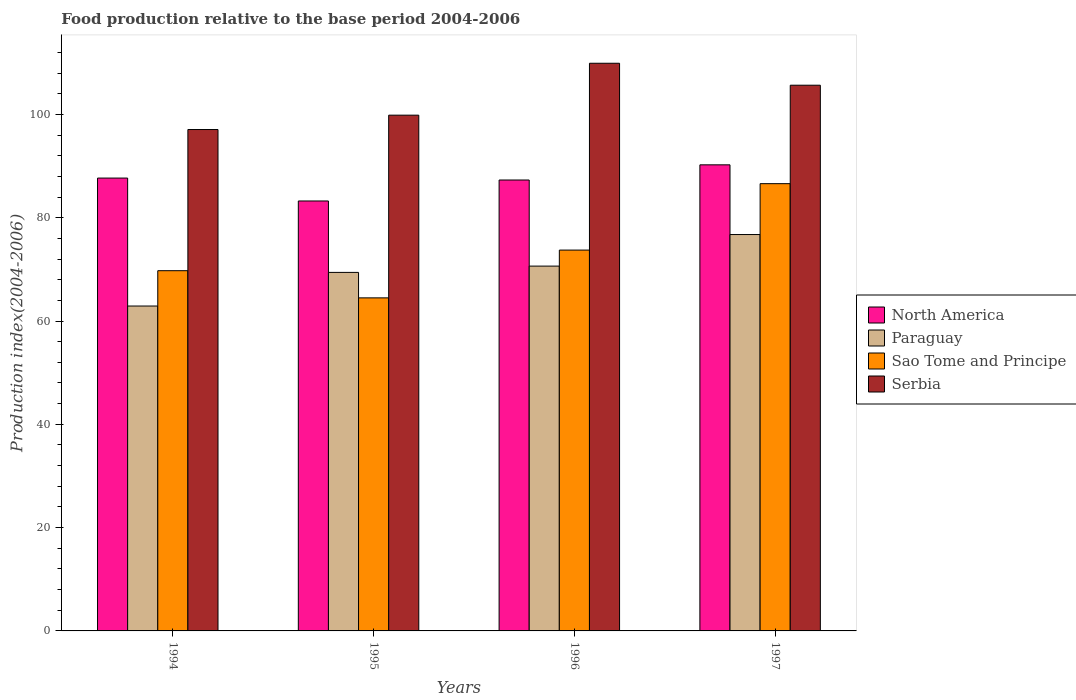How many different coloured bars are there?
Offer a very short reply. 4. Are the number of bars per tick equal to the number of legend labels?
Provide a succinct answer. Yes. How many bars are there on the 2nd tick from the left?
Provide a succinct answer. 4. What is the food production index in Serbia in 1995?
Keep it short and to the point. 99.85. Across all years, what is the maximum food production index in Paraguay?
Your response must be concise. 76.74. Across all years, what is the minimum food production index in Sao Tome and Principe?
Your answer should be compact. 64.48. In which year was the food production index in Sao Tome and Principe minimum?
Keep it short and to the point. 1995. What is the total food production index in Paraguay in the graph?
Your answer should be very brief. 279.68. What is the difference between the food production index in Sao Tome and Principe in 1994 and that in 1997?
Offer a terse response. -16.85. What is the difference between the food production index in Sao Tome and Principe in 1997 and the food production index in North America in 1994?
Keep it short and to the point. -1.08. What is the average food production index in Sao Tome and Principe per year?
Provide a succinct answer. 73.63. In the year 1994, what is the difference between the food production index in Serbia and food production index in North America?
Provide a succinct answer. 9.4. What is the ratio of the food production index in Sao Tome and Principe in 1995 to that in 1997?
Your response must be concise. 0.74. What is the difference between the highest and the second highest food production index in Sao Tome and Principe?
Offer a very short reply. 12.86. What is the difference between the highest and the lowest food production index in North America?
Offer a very short reply. 7. Is the sum of the food production index in North America in 1994 and 1995 greater than the maximum food production index in Paraguay across all years?
Your answer should be very brief. Yes. Is it the case that in every year, the sum of the food production index in Paraguay and food production index in North America is greater than the sum of food production index in Sao Tome and Principe and food production index in Serbia?
Offer a terse response. No. What does the 1st bar from the left in 1997 represents?
Your answer should be compact. North America. What does the 2nd bar from the right in 1997 represents?
Provide a succinct answer. Sao Tome and Principe. What is the difference between two consecutive major ticks on the Y-axis?
Offer a very short reply. 20. Does the graph contain grids?
Keep it short and to the point. No. Where does the legend appear in the graph?
Your answer should be compact. Center right. How many legend labels are there?
Ensure brevity in your answer.  4. How are the legend labels stacked?
Your answer should be very brief. Vertical. What is the title of the graph?
Provide a succinct answer. Food production relative to the base period 2004-2006. What is the label or title of the X-axis?
Give a very brief answer. Years. What is the label or title of the Y-axis?
Offer a very short reply. Production index(2004-2006). What is the Production index(2004-2006) of North America in 1994?
Offer a terse response. 87.67. What is the Production index(2004-2006) of Paraguay in 1994?
Make the answer very short. 62.9. What is the Production index(2004-2006) in Sao Tome and Principe in 1994?
Offer a terse response. 69.74. What is the Production index(2004-2006) in Serbia in 1994?
Give a very brief answer. 97.07. What is the Production index(2004-2006) in North America in 1995?
Ensure brevity in your answer.  83.24. What is the Production index(2004-2006) in Paraguay in 1995?
Your answer should be compact. 69.41. What is the Production index(2004-2006) in Sao Tome and Principe in 1995?
Provide a succinct answer. 64.48. What is the Production index(2004-2006) of Serbia in 1995?
Give a very brief answer. 99.85. What is the Production index(2004-2006) of North America in 1996?
Your answer should be compact. 87.3. What is the Production index(2004-2006) of Paraguay in 1996?
Provide a short and direct response. 70.63. What is the Production index(2004-2006) in Sao Tome and Principe in 1996?
Offer a very short reply. 73.73. What is the Production index(2004-2006) in Serbia in 1996?
Offer a terse response. 109.9. What is the Production index(2004-2006) in North America in 1997?
Make the answer very short. 90.24. What is the Production index(2004-2006) in Paraguay in 1997?
Your answer should be very brief. 76.74. What is the Production index(2004-2006) of Sao Tome and Principe in 1997?
Give a very brief answer. 86.59. What is the Production index(2004-2006) in Serbia in 1997?
Your answer should be very brief. 105.65. Across all years, what is the maximum Production index(2004-2006) of North America?
Offer a very short reply. 90.24. Across all years, what is the maximum Production index(2004-2006) of Paraguay?
Keep it short and to the point. 76.74. Across all years, what is the maximum Production index(2004-2006) of Sao Tome and Principe?
Make the answer very short. 86.59. Across all years, what is the maximum Production index(2004-2006) in Serbia?
Offer a terse response. 109.9. Across all years, what is the minimum Production index(2004-2006) in North America?
Offer a very short reply. 83.24. Across all years, what is the minimum Production index(2004-2006) of Paraguay?
Offer a terse response. 62.9. Across all years, what is the minimum Production index(2004-2006) of Sao Tome and Principe?
Make the answer very short. 64.48. Across all years, what is the minimum Production index(2004-2006) in Serbia?
Offer a very short reply. 97.07. What is the total Production index(2004-2006) of North America in the graph?
Keep it short and to the point. 348.44. What is the total Production index(2004-2006) of Paraguay in the graph?
Make the answer very short. 279.68. What is the total Production index(2004-2006) of Sao Tome and Principe in the graph?
Your answer should be compact. 294.54. What is the total Production index(2004-2006) of Serbia in the graph?
Your response must be concise. 412.47. What is the difference between the Production index(2004-2006) in North America in 1994 and that in 1995?
Ensure brevity in your answer.  4.44. What is the difference between the Production index(2004-2006) in Paraguay in 1994 and that in 1995?
Your response must be concise. -6.51. What is the difference between the Production index(2004-2006) of Sao Tome and Principe in 1994 and that in 1995?
Offer a very short reply. 5.26. What is the difference between the Production index(2004-2006) in Serbia in 1994 and that in 1995?
Ensure brevity in your answer.  -2.78. What is the difference between the Production index(2004-2006) in North America in 1994 and that in 1996?
Offer a terse response. 0.38. What is the difference between the Production index(2004-2006) of Paraguay in 1994 and that in 1996?
Your answer should be very brief. -7.73. What is the difference between the Production index(2004-2006) in Sao Tome and Principe in 1994 and that in 1996?
Your response must be concise. -3.99. What is the difference between the Production index(2004-2006) in Serbia in 1994 and that in 1996?
Make the answer very short. -12.83. What is the difference between the Production index(2004-2006) in North America in 1994 and that in 1997?
Make the answer very short. -2.56. What is the difference between the Production index(2004-2006) in Paraguay in 1994 and that in 1997?
Ensure brevity in your answer.  -13.84. What is the difference between the Production index(2004-2006) in Sao Tome and Principe in 1994 and that in 1997?
Give a very brief answer. -16.85. What is the difference between the Production index(2004-2006) in Serbia in 1994 and that in 1997?
Offer a terse response. -8.58. What is the difference between the Production index(2004-2006) in North America in 1995 and that in 1996?
Your response must be concise. -4.06. What is the difference between the Production index(2004-2006) in Paraguay in 1995 and that in 1996?
Give a very brief answer. -1.22. What is the difference between the Production index(2004-2006) in Sao Tome and Principe in 1995 and that in 1996?
Your response must be concise. -9.25. What is the difference between the Production index(2004-2006) in Serbia in 1995 and that in 1996?
Provide a short and direct response. -10.05. What is the difference between the Production index(2004-2006) in North America in 1995 and that in 1997?
Offer a terse response. -7. What is the difference between the Production index(2004-2006) in Paraguay in 1995 and that in 1997?
Provide a succinct answer. -7.33. What is the difference between the Production index(2004-2006) of Sao Tome and Principe in 1995 and that in 1997?
Keep it short and to the point. -22.11. What is the difference between the Production index(2004-2006) of North America in 1996 and that in 1997?
Your answer should be compact. -2.94. What is the difference between the Production index(2004-2006) of Paraguay in 1996 and that in 1997?
Your answer should be compact. -6.11. What is the difference between the Production index(2004-2006) of Sao Tome and Principe in 1996 and that in 1997?
Your answer should be very brief. -12.86. What is the difference between the Production index(2004-2006) in Serbia in 1996 and that in 1997?
Provide a succinct answer. 4.25. What is the difference between the Production index(2004-2006) of North America in 1994 and the Production index(2004-2006) of Paraguay in 1995?
Keep it short and to the point. 18.26. What is the difference between the Production index(2004-2006) of North America in 1994 and the Production index(2004-2006) of Sao Tome and Principe in 1995?
Provide a short and direct response. 23.19. What is the difference between the Production index(2004-2006) in North America in 1994 and the Production index(2004-2006) in Serbia in 1995?
Make the answer very short. -12.18. What is the difference between the Production index(2004-2006) in Paraguay in 1994 and the Production index(2004-2006) in Sao Tome and Principe in 1995?
Provide a succinct answer. -1.58. What is the difference between the Production index(2004-2006) of Paraguay in 1994 and the Production index(2004-2006) of Serbia in 1995?
Your response must be concise. -36.95. What is the difference between the Production index(2004-2006) in Sao Tome and Principe in 1994 and the Production index(2004-2006) in Serbia in 1995?
Keep it short and to the point. -30.11. What is the difference between the Production index(2004-2006) of North America in 1994 and the Production index(2004-2006) of Paraguay in 1996?
Ensure brevity in your answer.  17.04. What is the difference between the Production index(2004-2006) in North America in 1994 and the Production index(2004-2006) in Sao Tome and Principe in 1996?
Make the answer very short. 13.94. What is the difference between the Production index(2004-2006) of North America in 1994 and the Production index(2004-2006) of Serbia in 1996?
Offer a terse response. -22.23. What is the difference between the Production index(2004-2006) in Paraguay in 1994 and the Production index(2004-2006) in Sao Tome and Principe in 1996?
Provide a succinct answer. -10.83. What is the difference between the Production index(2004-2006) of Paraguay in 1994 and the Production index(2004-2006) of Serbia in 1996?
Keep it short and to the point. -47. What is the difference between the Production index(2004-2006) in Sao Tome and Principe in 1994 and the Production index(2004-2006) in Serbia in 1996?
Ensure brevity in your answer.  -40.16. What is the difference between the Production index(2004-2006) in North America in 1994 and the Production index(2004-2006) in Paraguay in 1997?
Make the answer very short. 10.93. What is the difference between the Production index(2004-2006) in North America in 1994 and the Production index(2004-2006) in Sao Tome and Principe in 1997?
Your answer should be compact. 1.08. What is the difference between the Production index(2004-2006) in North America in 1994 and the Production index(2004-2006) in Serbia in 1997?
Provide a succinct answer. -17.98. What is the difference between the Production index(2004-2006) in Paraguay in 1994 and the Production index(2004-2006) in Sao Tome and Principe in 1997?
Offer a very short reply. -23.69. What is the difference between the Production index(2004-2006) of Paraguay in 1994 and the Production index(2004-2006) of Serbia in 1997?
Provide a short and direct response. -42.75. What is the difference between the Production index(2004-2006) in Sao Tome and Principe in 1994 and the Production index(2004-2006) in Serbia in 1997?
Provide a succinct answer. -35.91. What is the difference between the Production index(2004-2006) of North America in 1995 and the Production index(2004-2006) of Paraguay in 1996?
Keep it short and to the point. 12.61. What is the difference between the Production index(2004-2006) in North America in 1995 and the Production index(2004-2006) in Sao Tome and Principe in 1996?
Provide a short and direct response. 9.51. What is the difference between the Production index(2004-2006) in North America in 1995 and the Production index(2004-2006) in Serbia in 1996?
Provide a succinct answer. -26.66. What is the difference between the Production index(2004-2006) in Paraguay in 1995 and the Production index(2004-2006) in Sao Tome and Principe in 1996?
Keep it short and to the point. -4.32. What is the difference between the Production index(2004-2006) in Paraguay in 1995 and the Production index(2004-2006) in Serbia in 1996?
Ensure brevity in your answer.  -40.49. What is the difference between the Production index(2004-2006) of Sao Tome and Principe in 1995 and the Production index(2004-2006) of Serbia in 1996?
Provide a succinct answer. -45.42. What is the difference between the Production index(2004-2006) of North America in 1995 and the Production index(2004-2006) of Paraguay in 1997?
Offer a terse response. 6.5. What is the difference between the Production index(2004-2006) in North America in 1995 and the Production index(2004-2006) in Sao Tome and Principe in 1997?
Your answer should be compact. -3.35. What is the difference between the Production index(2004-2006) in North America in 1995 and the Production index(2004-2006) in Serbia in 1997?
Your answer should be compact. -22.41. What is the difference between the Production index(2004-2006) of Paraguay in 1995 and the Production index(2004-2006) of Sao Tome and Principe in 1997?
Keep it short and to the point. -17.18. What is the difference between the Production index(2004-2006) in Paraguay in 1995 and the Production index(2004-2006) in Serbia in 1997?
Your answer should be compact. -36.24. What is the difference between the Production index(2004-2006) of Sao Tome and Principe in 1995 and the Production index(2004-2006) of Serbia in 1997?
Ensure brevity in your answer.  -41.17. What is the difference between the Production index(2004-2006) in North America in 1996 and the Production index(2004-2006) in Paraguay in 1997?
Offer a terse response. 10.56. What is the difference between the Production index(2004-2006) of North America in 1996 and the Production index(2004-2006) of Sao Tome and Principe in 1997?
Your answer should be compact. 0.71. What is the difference between the Production index(2004-2006) of North America in 1996 and the Production index(2004-2006) of Serbia in 1997?
Offer a very short reply. -18.35. What is the difference between the Production index(2004-2006) in Paraguay in 1996 and the Production index(2004-2006) in Sao Tome and Principe in 1997?
Provide a succinct answer. -15.96. What is the difference between the Production index(2004-2006) of Paraguay in 1996 and the Production index(2004-2006) of Serbia in 1997?
Make the answer very short. -35.02. What is the difference between the Production index(2004-2006) in Sao Tome and Principe in 1996 and the Production index(2004-2006) in Serbia in 1997?
Your answer should be very brief. -31.92. What is the average Production index(2004-2006) in North America per year?
Your answer should be compact. 87.11. What is the average Production index(2004-2006) in Paraguay per year?
Your answer should be very brief. 69.92. What is the average Production index(2004-2006) of Sao Tome and Principe per year?
Provide a succinct answer. 73.64. What is the average Production index(2004-2006) in Serbia per year?
Your answer should be compact. 103.12. In the year 1994, what is the difference between the Production index(2004-2006) of North America and Production index(2004-2006) of Paraguay?
Keep it short and to the point. 24.77. In the year 1994, what is the difference between the Production index(2004-2006) in North America and Production index(2004-2006) in Sao Tome and Principe?
Your response must be concise. 17.93. In the year 1994, what is the difference between the Production index(2004-2006) in North America and Production index(2004-2006) in Serbia?
Your response must be concise. -9.4. In the year 1994, what is the difference between the Production index(2004-2006) in Paraguay and Production index(2004-2006) in Sao Tome and Principe?
Make the answer very short. -6.84. In the year 1994, what is the difference between the Production index(2004-2006) in Paraguay and Production index(2004-2006) in Serbia?
Provide a succinct answer. -34.17. In the year 1994, what is the difference between the Production index(2004-2006) in Sao Tome and Principe and Production index(2004-2006) in Serbia?
Offer a terse response. -27.33. In the year 1995, what is the difference between the Production index(2004-2006) in North America and Production index(2004-2006) in Paraguay?
Give a very brief answer. 13.83. In the year 1995, what is the difference between the Production index(2004-2006) in North America and Production index(2004-2006) in Sao Tome and Principe?
Offer a very short reply. 18.76. In the year 1995, what is the difference between the Production index(2004-2006) of North America and Production index(2004-2006) of Serbia?
Ensure brevity in your answer.  -16.61. In the year 1995, what is the difference between the Production index(2004-2006) in Paraguay and Production index(2004-2006) in Sao Tome and Principe?
Provide a short and direct response. 4.93. In the year 1995, what is the difference between the Production index(2004-2006) in Paraguay and Production index(2004-2006) in Serbia?
Your answer should be compact. -30.44. In the year 1995, what is the difference between the Production index(2004-2006) of Sao Tome and Principe and Production index(2004-2006) of Serbia?
Offer a terse response. -35.37. In the year 1996, what is the difference between the Production index(2004-2006) of North America and Production index(2004-2006) of Paraguay?
Make the answer very short. 16.67. In the year 1996, what is the difference between the Production index(2004-2006) of North America and Production index(2004-2006) of Sao Tome and Principe?
Offer a very short reply. 13.57. In the year 1996, what is the difference between the Production index(2004-2006) in North America and Production index(2004-2006) in Serbia?
Make the answer very short. -22.6. In the year 1996, what is the difference between the Production index(2004-2006) in Paraguay and Production index(2004-2006) in Serbia?
Offer a very short reply. -39.27. In the year 1996, what is the difference between the Production index(2004-2006) of Sao Tome and Principe and Production index(2004-2006) of Serbia?
Ensure brevity in your answer.  -36.17. In the year 1997, what is the difference between the Production index(2004-2006) of North America and Production index(2004-2006) of Paraguay?
Give a very brief answer. 13.5. In the year 1997, what is the difference between the Production index(2004-2006) of North America and Production index(2004-2006) of Sao Tome and Principe?
Your response must be concise. 3.65. In the year 1997, what is the difference between the Production index(2004-2006) in North America and Production index(2004-2006) in Serbia?
Offer a terse response. -15.41. In the year 1997, what is the difference between the Production index(2004-2006) of Paraguay and Production index(2004-2006) of Sao Tome and Principe?
Keep it short and to the point. -9.85. In the year 1997, what is the difference between the Production index(2004-2006) of Paraguay and Production index(2004-2006) of Serbia?
Provide a short and direct response. -28.91. In the year 1997, what is the difference between the Production index(2004-2006) of Sao Tome and Principe and Production index(2004-2006) of Serbia?
Provide a short and direct response. -19.06. What is the ratio of the Production index(2004-2006) of North America in 1994 to that in 1995?
Keep it short and to the point. 1.05. What is the ratio of the Production index(2004-2006) in Paraguay in 1994 to that in 1995?
Your response must be concise. 0.91. What is the ratio of the Production index(2004-2006) of Sao Tome and Principe in 1994 to that in 1995?
Your response must be concise. 1.08. What is the ratio of the Production index(2004-2006) of Serbia in 1994 to that in 1995?
Your response must be concise. 0.97. What is the ratio of the Production index(2004-2006) of Paraguay in 1994 to that in 1996?
Ensure brevity in your answer.  0.89. What is the ratio of the Production index(2004-2006) of Sao Tome and Principe in 1994 to that in 1996?
Ensure brevity in your answer.  0.95. What is the ratio of the Production index(2004-2006) in Serbia in 1994 to that in 1996?
Your answer should be very brief. 0.88. What is the ratio of the Production index(2004-2006) of North America in 1994 to that in 1997?
Your answer should be very brief. 0.97. What is the ratio of the Production index(2004-2006) in Paraguay in 1994 to that in 1997?
Provide a succinct answer. 0.82. What is the ratio of the Production index(2004-2006) of Sao Tome and Principe in 1994 to that in 1997?
Keep it short and to the point. 0.81. What is the ratio of the Production index(2004-2006) in Serbia in 1994 to that in 1997?
Ensure brevity in your answer.  0.92. What is the ratio of the Production index(2004-2006) of North America in 1995 to that in 1996?
Ensure brevity in your answer.  0.95. What is the ratio of the Production index(2004-2006) in Paraguay in 1995 to that in 1996?
Your answer should be very brief. 0.98. What is the ratio of the Production index(2004-2006) of Sao Tome and Principe in 1995 to that in 1996?
Your response must be concise. 0.87. What is the ratio of the Production index(2004-2006) in Serbia in 1995 to that in 1996?
Ensure brevity in your answer.  0.91. What is the ratio of the Production index(2004-2006) of North America in 1995 to that in 1997?
Your answer should be very brief. 0.92. What is the ratio of the Production index(2004-2006) in Paraguay in 1995 to that in 1997?
Your answer should be very brief. 0.9. What is the ratio of the Production index(2004-2006) of Sao Tome and Principe in 1995 to that in 1997?
Give a very brief answer. 0.74. What is the ratio of the Production index(2004-2006) in Serbia in 1995 to that in 1997?
Ensure brevity in your answer.  0.95. What is the ratio of the Production index(2004-2006) of North America in 1996 to that in 1997?
Give a very brief answer. 0.97. What is the ratio of the Production index(2004-2006) in Paraguay in 1996 to that in 1997?
Provide a short and direct response. 0.92. What is the ratio of the Production index(2004-2006) of Sao Tome and Principe in 1996 to that in 1997?
Offer a terse response. 0.85. What is the ratio of the Production index(2004-2006) in Serbia in 1996 to that in 1997?
Offer a terse response. 1.04. What is the difference between the highest and the second highest Production index(2004-2006) in North America?
Your answer should be very brief. 2.56. What is the difference between the highest and the second highest Production index(2004-2006) of Paraguay?
Provide a succinct answer. 6.11. What is the difference between the highest and the second highest Production index(2004-2006) of Sao Tome and Principe?
Provide a succinct answer. 12.86. What is the difference between the highest and the second highest Production index(2004-2006) of Serbia?
Your response must be concise. 4.25. What is the difference between the highest and the lowest Production index(2004-2006) in North America?
Your answer should be very brief. 7. What is the difference between the highest and the lowest Production index(2004-2006) in Paraguay?
Provide a succinct answer. 13.84. What is the difference between the highest and the lowest Production index(2004-2006) of Sao Tome and Principe?
Offer a very short reply. 22.11. What is the difference between the highest and the lowest Production index(2004-2006) of Serbia?
Your answer should be very brief. 12.83. 